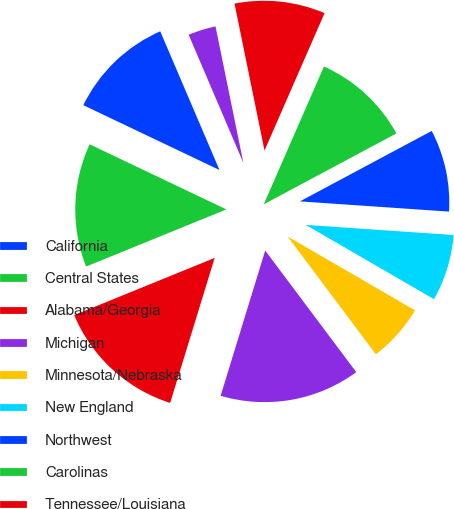<chart> <loc_0><loc_0><loc_500><loc_500><pie_chart><fcel>California<fcel>Central States<fcel>Alabama/Georgia<fcel>Michigan<fcel>Minnesota/Nebraska<fcel>New England<fcel>Northwest<fcel>Carolinas<fcel>Tennessee/Louisiana<fcel>Texas<nl><fcel>11.5%<fcel>13.23%<fcel>14.1%<fcel>14.97%<fcel>6.41%<fcel>7.27%<fcel>8.9%<fcel>10.63%<fcel>9.76%<fcel>3.22%<nl></chart> 